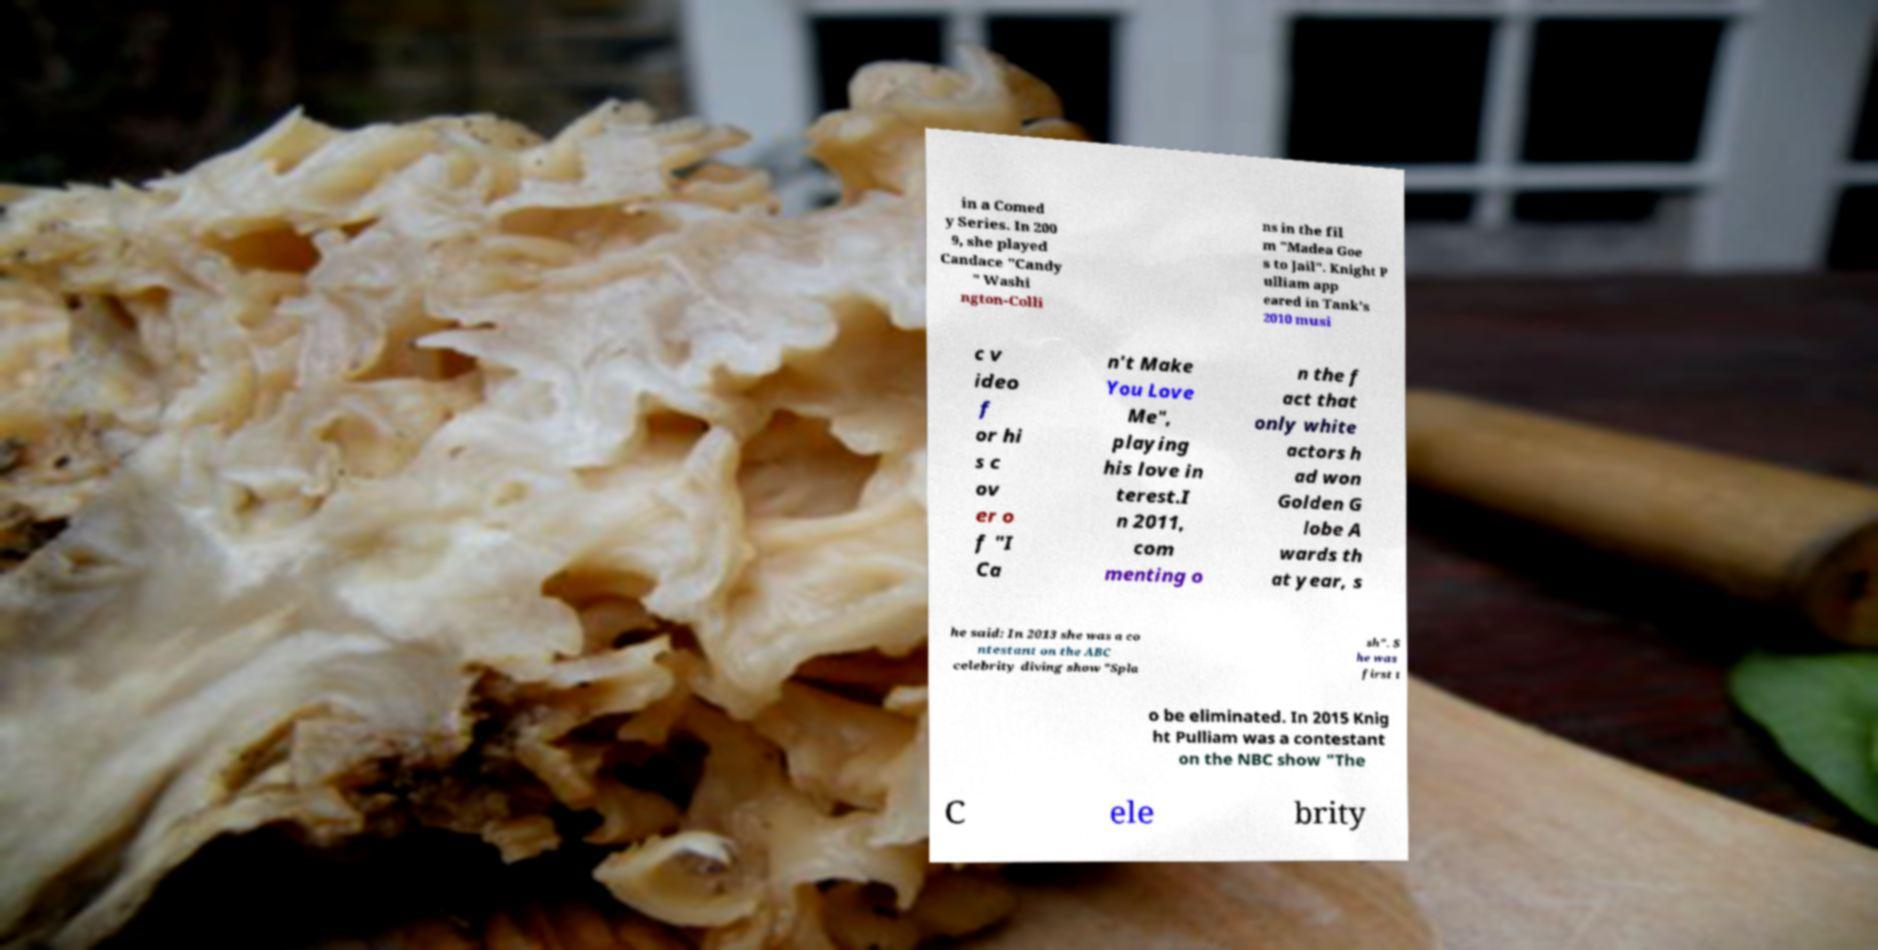What messages or text are displayed in this image? I need them in a readable, typed format. in a Comed y Series. In 200 9, she played Candace "Candy " Washi ngton-Colli ns in the fil m "Madea Goe s to Jail". Knight P ulliam app eared in Tank's 2010 musi c v ideo f or hi s c ov er o f "I Ca n't Make You Love Me", playing his love in terest.I n 2011, com menting o n the f act that only white actors h ad won Golden G lobe A wards th at year, s he said: In 2013 she was a co ntestant on the ABC celebrity diving show "Spla sh". S he was first t o be eliminated. In 2015 Knig ht Pulliam was a contestant on the NBC show "The C ele brity 